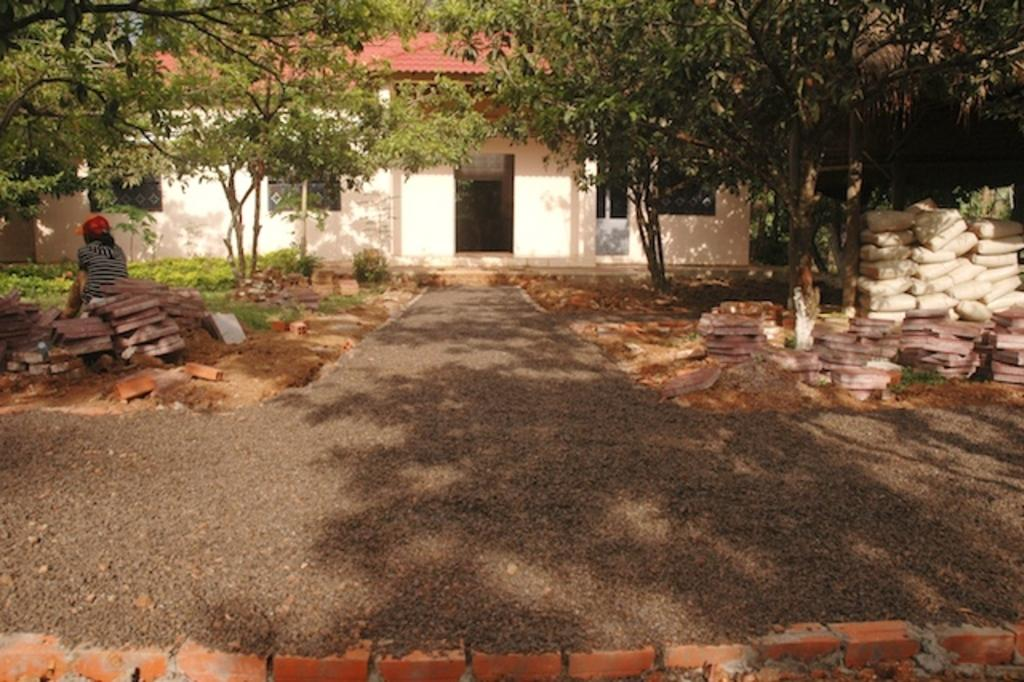What type of surface can be seen in the image? There is a grass surface with tiles placed near it in the image. What is the main feature of the grass surface? There is a path on the grass surface in the image. What can be seen in the background of the image? There is a house in the background of the image. What are the features of the house? The house has a door and windows. What type of holiday is being celebrated in the image? A: There is no indication of a holiday being celebrated in the image. What type of industry is depicted in the image? There is no industry depicted in the image; it features a path, grass surface, tiles, and a house. 